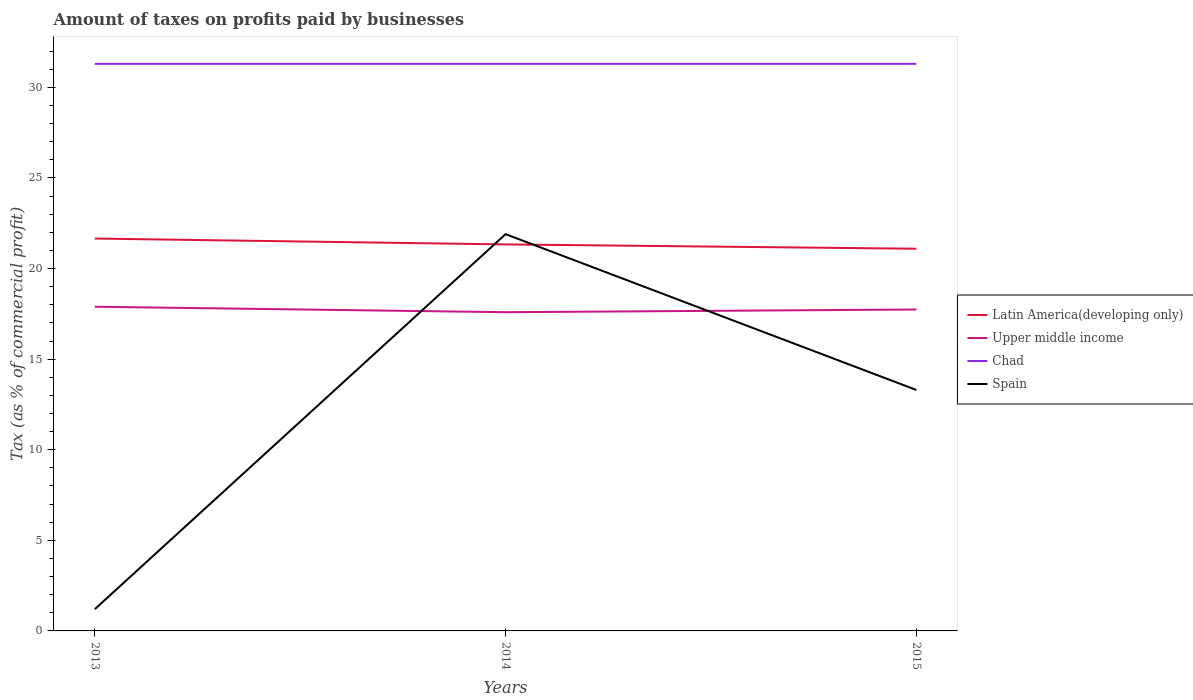How many different coloured lines are there?
Provide a short and direct response. 4. Does the line corresponding to Spain intersect with the line corresponding to Chad?
Ensure brevity in your answer.  No. Across all years, what is the maximum percentage of taxes paid by businesses in Chad?
Offer a terse response. 31.3. What is the total percentage of taxes paid by businesses in Upper middle income in the graph?
Ensure brevity in your answer.  0.15. What is the difference between the highest and the second highest percentage of taxes paid by businesses in Latin America(developing only)?
Your answer should be compact. 0.56. Is the percentage of taxes paid by businesses in Spain strictly greater than the percentage of taxes paid by businesses in Chad over the years?
Provide a short and direct response. Yes. What is the difference between two consecutive major ticks on the Y-axis?
Offer a very short reply. 5. Are the values on the major ticks of Y-axis written in scientific E-notation?
Make the answer very short. No. Does the graph contain any zero values?
Make the answer very short. No. Does the graph contain grids?
Offer a terse response. No. What is the title of the graph?
Your response must be concise. Amount of taxes on profits paid by businesses. What is the label or title of the X-axis?
Give a very brief answer. Years. What is the label or title of the Y-axis?
Provide a short and direct response. Tax (as % of commercial profit). What is the Tax (as % of commercial profit) of Latin America(developing only) in 2013?
Keep it short and to the point. 21.66. What is the Tax (as % of commercial profit) of Upper middle income in 2013?
Your answer should be compact. 17.89. What is the Tax (as % of commercial profit) in Chad in 2013?
Provide a succinct answer. 31.3. What is the Tax (as % of commercial profit) in Latin America(developing only) in 2014?
Provide a short and direct response. 21.33. What is the Tax (as % of commercial profit) of Upper middle income in 2014?
Provide a succinct answer. 17.59. What is the Tax (as % of commercial profit) in Chad in 2014?
Ensure brevity in your answer.  31.3. What is the Tax (as % of commercial profit) of Spain in 2014?
Offer a terse response. 21.9. What is the Tax (as % of commercial profit) in Latin America(developing only) in 2015?
Give a very brief answer. 21.1. What is the Tax (as % of commercial profit) of Upper middle income in 2015?
Your answer should be compact. 17.74. What is the Tax (as % of commercial profit) in Chad in 2015?
Offer a very short reply. 31.3. What is the Tax (as % of commercial profit) in Spain in 2015?
Ensure brevity in your answer.  13.3. Across all years, what is the maximum Tax (as % of commercial profit) of Latin America(developing only)?
Your answer should be compact. 21.66. Across all years, what is the maximum Tax (as % of commercial profit) of Upper middle income?
Offer a terse response. 17.89. Across all years, what is the maximum Tax (as % of commercial profit) of Chad?
Your answer should be compact. 31.3. Across all years, what is the maximum Tax (as % of commercial profit) in Spain?
Your response must be concise. 21.9. Across all years, what is the minimum Tax (as % of commercial profit) in Latin America(developing only)?
Ensure brevity in your answer.  21.1. Across all years, what is the minimum Tax (as % of commercial profit) of Upper middle income?
Provide a short and direct response. 17.59. Across all years, what is the minimum Tax (as % of commercial profit) of Chad?
Your answer should be very brief. 31.3. What is the total Tax (as % of commercial profit) of Latin America(developing only) in the graph?
Provide a succinct answer. 64.09. What is the total Tax (as % of commercial profit) of Upper middle income in the graph?
Make the answer very short. 53.23. What is the total Tax (as % of commercial profit) in Chad in the graph?
Your answer should be very brief. 93.9. What is the total Tax (as % of commercial profit) of Spain in the graph?
Give a very brief answer. 36.4. What is the difference between the Tax (as % of commercial profit) in Latin America(developing only) in 2013 and that in 2014?
Keep it short and to the point. 0.32. What is the difference between the Tax (as % of commercial profit) of Upper middle income in 2013 and that in 2014?
Your answer should be compact. 0.3. What is the difference between the Tax (as % of commercial profit) of Chad in 2013 and that in 2014?
Your answer should be very brief. 0. What is the difference between the Tax (as % of commercial profit) of Spain in 2013 and that in 2014?
Offer a very short reply. -20.7. What is the difference between the Tax (as % of commercial profit) in Latin America(developing only) in 2013 and that in 2015?
Provide a short and direct response. 0.56. What is the difference between the Tax (as % of commercial profit) in Upper middle income in 2013 and that in 2015?
Give a very brief answer. 0.15. What is the difference between the Tax (as % of commercial profit) in Spain in 2013 and that in 2015?
Provide a short and direct response. -12.1. What is the difference between the Tax (as % of commercial profit) of Latin America(developing only) in 2014 and that in 2015?
Offer a terse response. 0.24. What is the difference between the Tax (as % of commercial profit) in Chad in 2014 and that in 2015?
Your answer should be compact. 0. What is the difference between the Tax (as % of commercial profit) of Latin America(developing only) in 2013 and the Tax (as % of commercial profit) of Upper middle income in 2014?
Offer a terse response. 4.07. What is the difference between the Tax (as % of commercial profit) of Latin America(developing only) in 2013 and the Tax (as % of commercial profit) of Chad in 2014?
Your answer should be very brief. -9.64. What is the difference between the Tax (as % of commercial profit) in Latin America(developing only) in 2013 and the Tax (as % of commercial profit) in Spain in 2014?
Keep it short and to the point. -0.24. What is the difference between the Tax (as % of commercial profit) of Upper middle income in 2013 and the Tax (as % of commercial profit) of Chad in 2014?
Offer a very short reply. -13.41. What is the difference between the Tax (as % of commercial profit) in Upper middle income in 2013 and the Tax (as % of commercial profit) in Spain in 2014?
Offer a very short reply. -4.01. What is the difference between the Tax (as % of commercial profit) of Latin America(developing only) in 2013 and the Tax (as % of commercial profit) of Upper middle income in 2015?
Make the answer very short. 3.92. What is the difference between the Tax (as % of commercial profit) in Latin America(developing only) in 2013 and the Tax (as % of commercial profit) in Chad in 2015?
Offer a terse response. -9.64. What is the difference between the Tax (as % of commercial profit) of Latin America(developing only) in 2013 and the Tax (as % of commercial profit) of Spain in 2015?
Make the answer very short. 8.36. What is the difference between the Tax (as % of commercial profit) in Upper middle income in 2013 and the Tax (as % of commercial profit) in Chad in 2015?
Offer a terse response. -13.41. What is the difference between the Tax (as % of commercial profit) of Upper middle income in 2013 and the Tax (as % of commercial profit) of Spain in 2015?
Provide a short and direct response. 4.59. What is the difference between the Tax (as % of commercial profit) of Latin America(developing only) in 2014 and the Tax (as % of commercial profit) of Upper middle income in 2015?
Keep it short and to the point. 3.59. What is the difference between the Tax (as % of commercial profit) in Latin America(developing only) in 2014 and the Tax (as % of commercial profit) in Chad in 2015?
Provide a succinct answer. -9.97. What is the difference between the Tax (as % of commercial profit) in Latin America(developing only) in 2014 and the Tax (as % of commercial profit) in Spain in 2015?
Your answer should be compact. 8.03. What is the difference between the Tax (as % of commercial profit) of Upper middle income in 2014 and the Tax (as % of commercial profit) of Chad in 2015?
Provide a succinct answer. -13.71. What is the difference between the Tax (as % of commercial profit) of Upper middle income in 2014 and the Tax (as % of commercial profit) of Spain in 2015?
Provide a short and direct response. 4.29. What is the difference between the Tax (as % of commercial profit) in Chad in 2014 and the Tax (as % of commercial profit) in Spain in 2015?
Offer a terse response. 18. What is the average Tax (as % of commercial profit) in Latin America(developing only) per year?
Make the answer very short. 21.36. What is the average Tax (as % of commercial profit) in Upper middle income per year?
Provide a short and direct response. 17.74. What is the average Tax (as % of commercial profit) in Chad per year?
Offer a terse response. 31.3. What is the average Tax (as % of commercial profit) in Spain per year?
Keep it short and to the point. 12.13. In the year 2013, what is the difference between the Tax (as % of commercial profit) in Latin America(developing only) and Tax (as % of commercial profit) in Upper middle income?
Offer a very short reply. 3.76. In the year 2013, what is the difference between the Tax (as % of commercial profit) of Latin America(developing only) and Tax (as % of commercial profit) of Chad?
Keep it short and to the point. -9.64. In the year 2013, what is the difference between the Tax (as % of commercial profit) in Latin America(developing only) and Tax (as % of commercial profit) in Spain?
Your response must be concise. 20.46. In the year 2013, what is the difference between the Tax (as % of commercial profit) in Upper middle income and Tax (as % of commercial profit) in Chad?
Your answer should be compact. -13.41. In the year 2013, what is the difference between the Tax (as % of commercial profit) of Upper middle income and Tax (as % of commercial profit) of Spain?
Ensure brevity in your answer.  16.69. In the year 2013, what is the difference between the Tax (as % of commercial profit) of Chad and Tax (as % of commercial profit) of Spain?
Keep it short and to the point. 30.1. In the year 2014, what is the difference between the Tax (as % of commercial profit) in Latin America(developing only) and Tax (as % of commercial profit) in Upper middle income?
Provide a short and direct response. 3.74. In the year 2014, what is the difference between the Tax (as % of commercial profit) of Latin America(developing only) and Tax (as % of commercial profit) of Chad?
Provide a succinct answer. -9.97. In the year 2014, what is the difference between the Tax (as % of commercial profit) of Latin America(developing only) and Tax (as % of commercial profit) of Spain?
Keep it short and to the point. -0.57. In the year 2014, what is the difference between the Tax (as % of commercial profit) in Upper middle income and Tax (as % of commercial profit) in Chad?
Offer a terse response. -13.71. In the year 2014, what is the difference between the Tax (as % of commercial profit) in Upper middle income and Tax (as % of commercial profit) in Spain?
Your response must be concise. -4.31. In the year 2014, what is the difference between the Tax (as % of commercial profit) in Chad and Tax (as % of commercial profit) in Spain?
Provide a succinct answer. 9.4. In the year 2015, what is the difference between the Tax (as % of commercial profit) in Latin America(developing only) and Tax (as % of commercial profit) in Upper middle income?
Your answer should be compact. 3.35. In the year 2015, what is the difference between the Tax (as % of commercial profit) of Latin America(developing only) and Tax (as % of commercial profit) of Chad?
Offer a terse response. -10.2. In the year 2015, what is the difference between the Tax (as % of commercial profit) in Latin America(developing only) and Tax (as % of commercial profit) in Spain?
Make the answer very short. 7.8. In the year 2015, what is the difference between the Tax (as % of commercial profit) of Upper middle income and Tax (as % of commercial profit) of Chad?
Offer a terse response. -13.56. In the year 2015, what is the difference between the Tax (as % of commercial profit) of Upper middle income and Tax (as % of commercial profit) of Spain?
Ensure brevity in your answer.  4.44. What is the ratio of the Tax (as % of commercial profit) of Latin America(developing only) in 2013 to that in 2014?
Make the answer very short. 1.02. What is the ratio of the Tax (as % of commercial profit) in Upper middle income in 2013 to that in 2014?
Ensure brevity in your answer.  1.02. What is the ratio of the Tax (as % of commercial profit) of Chad in 2013 to that in 2014?
Ensure brevity in your answer.  1. What is the ratio of the Tax (as % of commercial profit) of Spain in 2013 to that in 2014?
Offer a very short reply. 0.05. What is the ratio of the Tax (as % of commercial profit) of Latin America(developing only) in 2013 to that in 2015?
Keep it short and to the point. 1.03. What is the ratio of the Tax (as % of commercial profit) of Upper middle income in 2013 to that in 2015?
Provide a succinct answer. 1.01. What is the ratio of the Tax (as % of commercial profit) in Spain in 2013 to that in 2015?
Provide a succinct answer. 0.09. What is the ratio of the Tax (as % of commercial profit) in Latin America(developing only) in 2014 to that in 2015?
Your response must be concise. 1.01. What is the ratio of the Tax (as % of commercial profit) of Chad in 2014 to that in 2015?
Ensure brevity in your answer.  1. What is the ratio of the Tax (as % of commercial profit) in Spain in 2014 to that in 2015?
Your response must be concise. 1.65. What is the difference between the highest and the second highest Tax (as % of commercial profit) of Latin America(developing only)?
Your answer should be very brief. 0.32. What is the difference between the highest and the second highest Tax (as % of commercial profit) of Upper middle income?
Provide a short and direct response. 0.15. What is the difference between the highest and the second highest Tax (as % of commercial profit) in Chad?
Your response must be concise. 0. What is the difference between the highest and the second highest Tax (as % of commercial profit) in Spain?
Provide a short and direct response. 8.6. What is the difference between the highest and the lowest Tax (as % of commercial profit) in Latin America(developing only)?
Your answer should be very brief. 0.56. What is the difference between the highest and the lowest Tax (as % of commercial profit) of Upper middle income?
Ensure brevity in your answer.  0.3. What is the difference between the highest and the lowest Tax (as % of commercial profit) in Chad?
Offer a terse response. 0. What is the difference between the highest and the lowest Tax (as % of commercial profit) in Spain?
Offer a terse response. 20.7. 